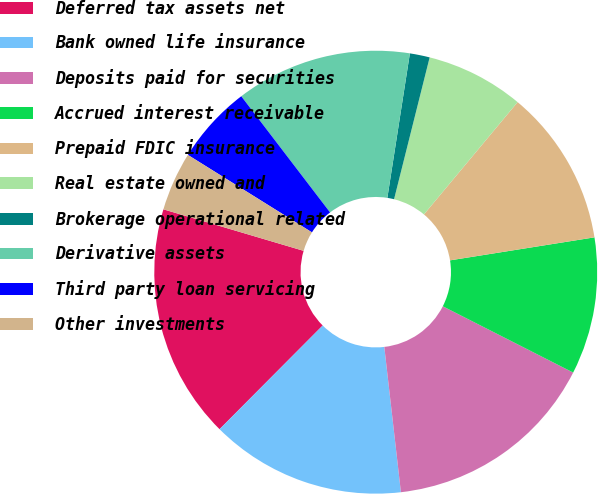Convert chart to OTSL. <chart><loc_0><loc_0><loc_500><loc_500><pie_chart><fcel>Deferred tax assets net<fcel>Bank owned life insurance<fcel>Deposits paid for securities<fcel>Accrued interest receivable<fcel>Prepaid FDIC insurance<fcel>Real estate owned and<fcel>Brokerage operational related<fcel>Derivative assets<fcel>Third party loan servicing<fcel>Other investments<nl><fcel>17.12%<fcel>14.27%<fcel>15.7%<fcel>10.0%<fcel>11.42%<fcel>7.15%<fcel>1.45%<fcel>12.85%<fcel>5.73%<fcel>4.3%<nl></chart> 